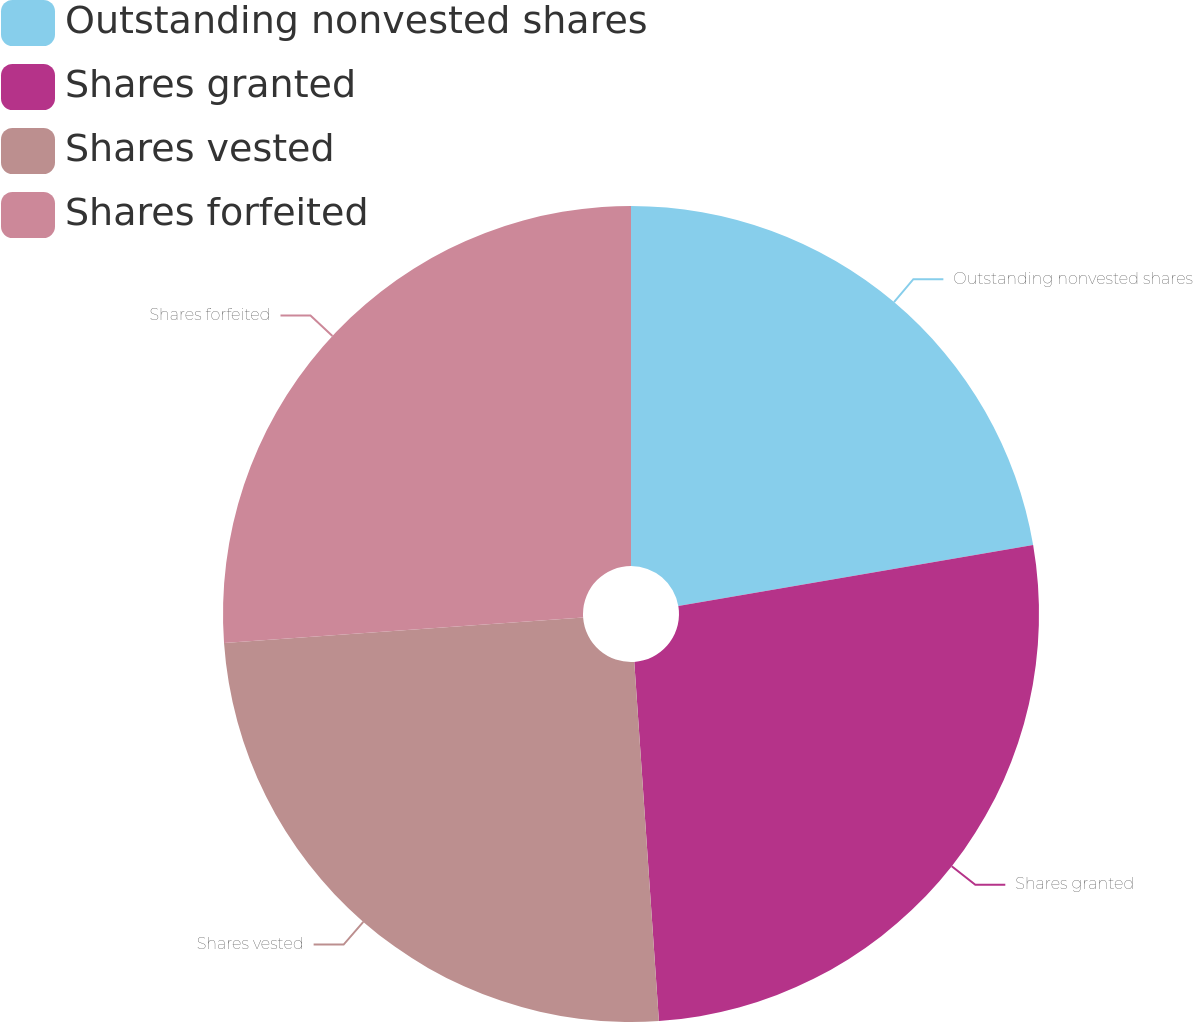Convert chart to OTSL. <chart><loc_0><loc_0><loc_500><loc_500><pie_chart><fcel>Outstanding nonvested shares<fcel>Shares granted<fcel>Shares vested<fcel>Shares forfeited<nl><fcel>22.3%<fcel>26.61%<fcel>24.96%<fcel>26.13%<nl></chart> 